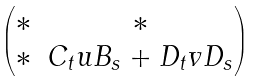Convert formula to latex. <formula><loc_0><loc_0><loc_500><loc_500>\begin{pmatrix} * & * \\ * & C _ { t } u B _ { s } + D _ { t } v D _ { s } \end{pmatrix}</formula> 